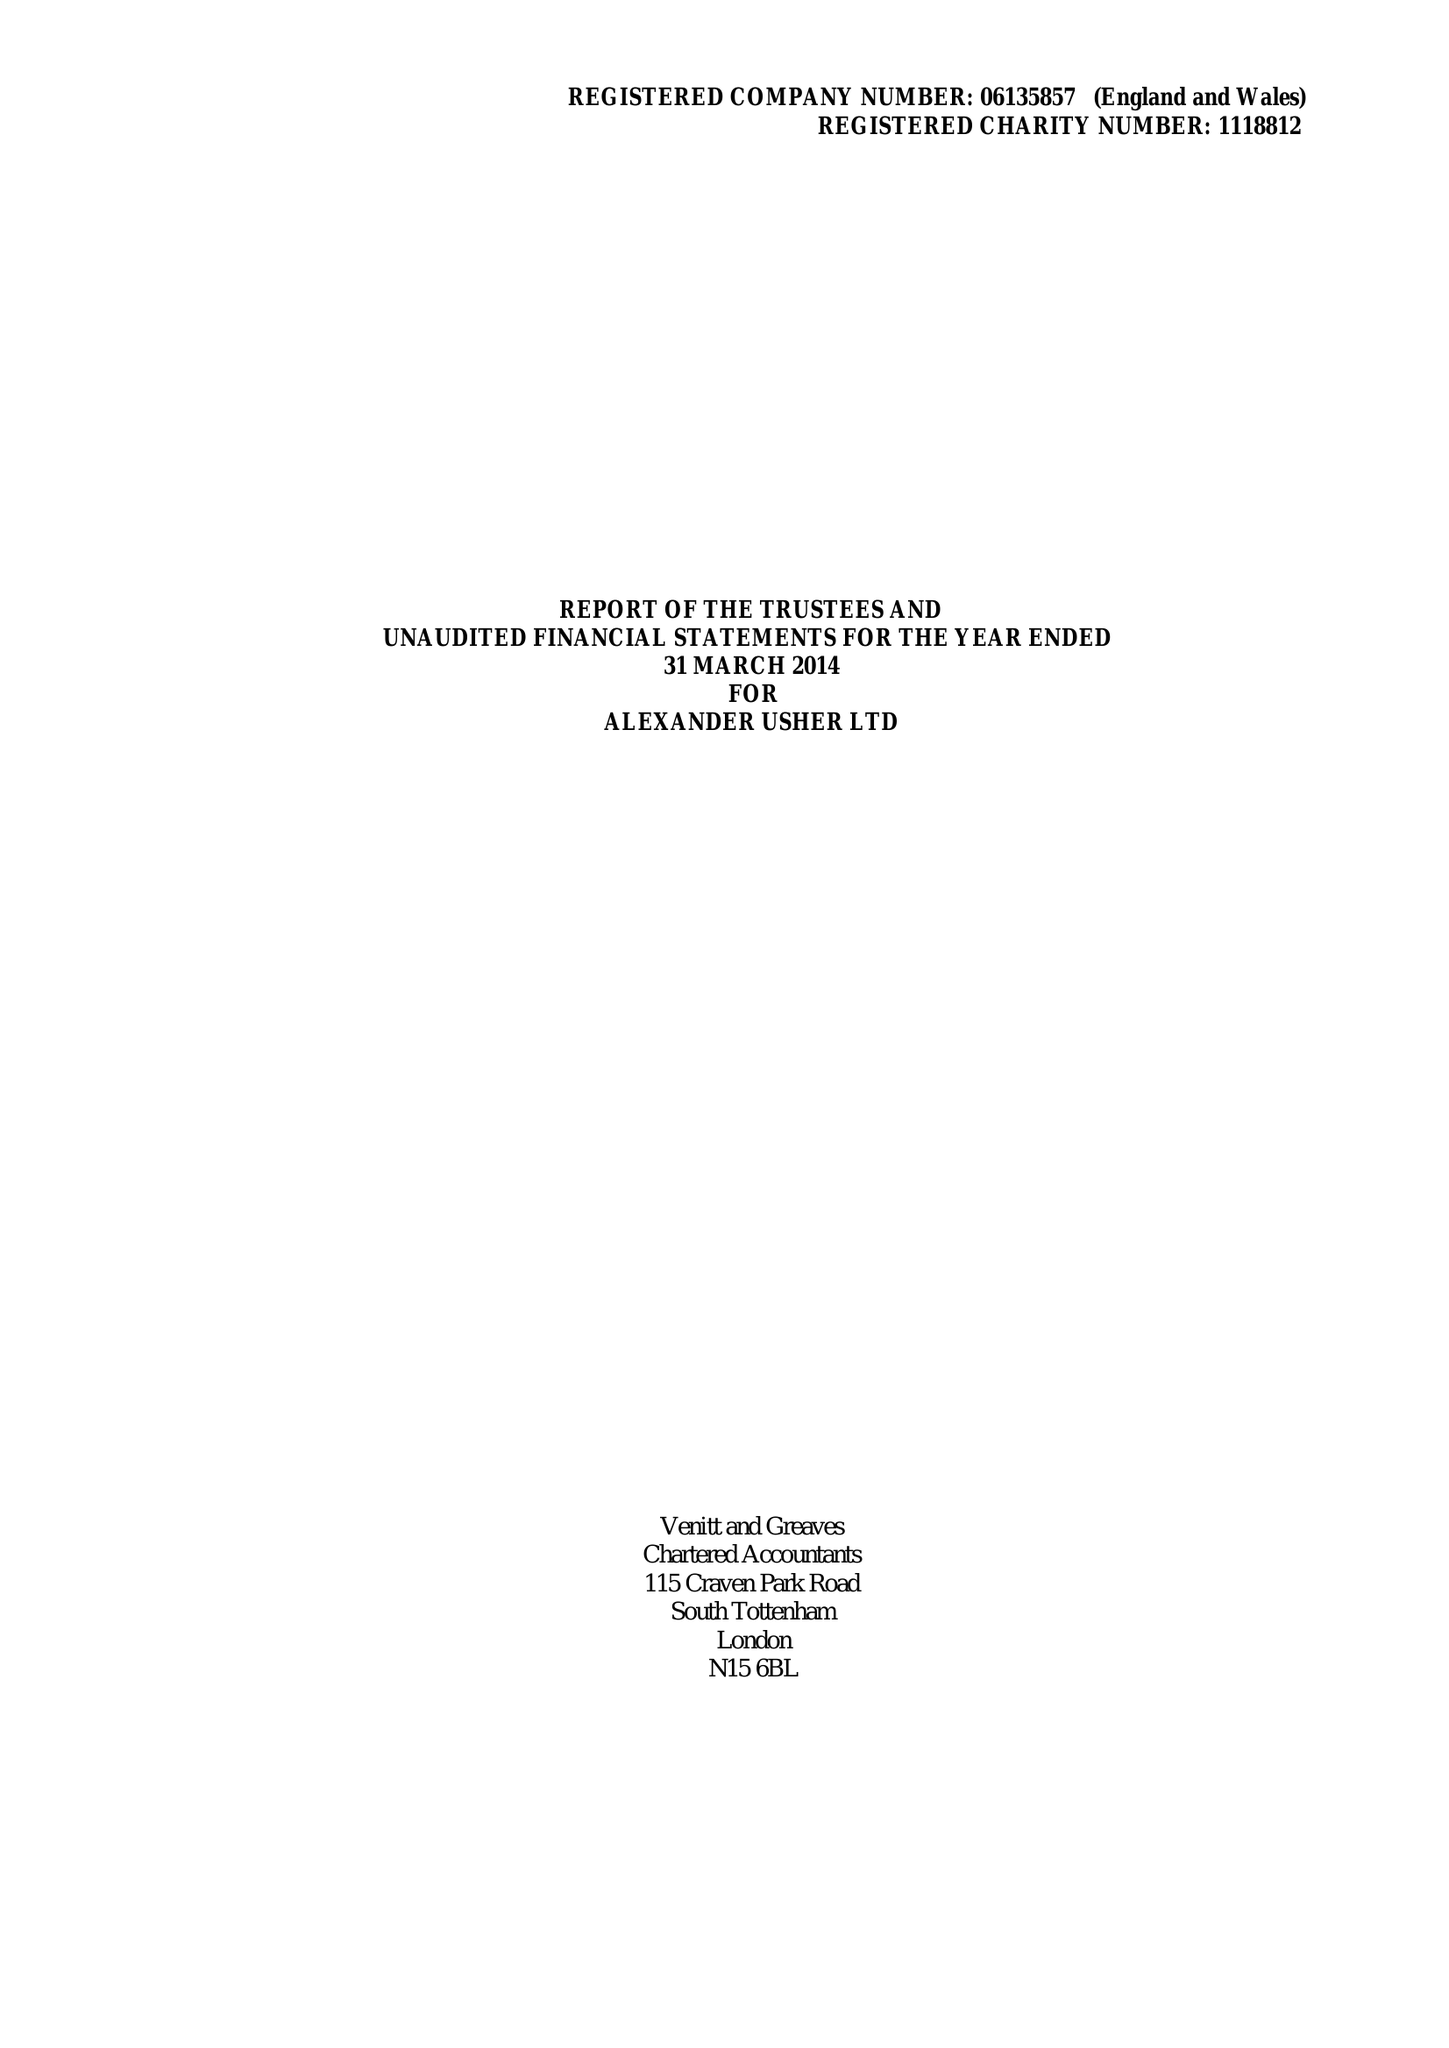What is the value for the address__postcode?
Answer the question using a single word or phrase. N15 6BL 